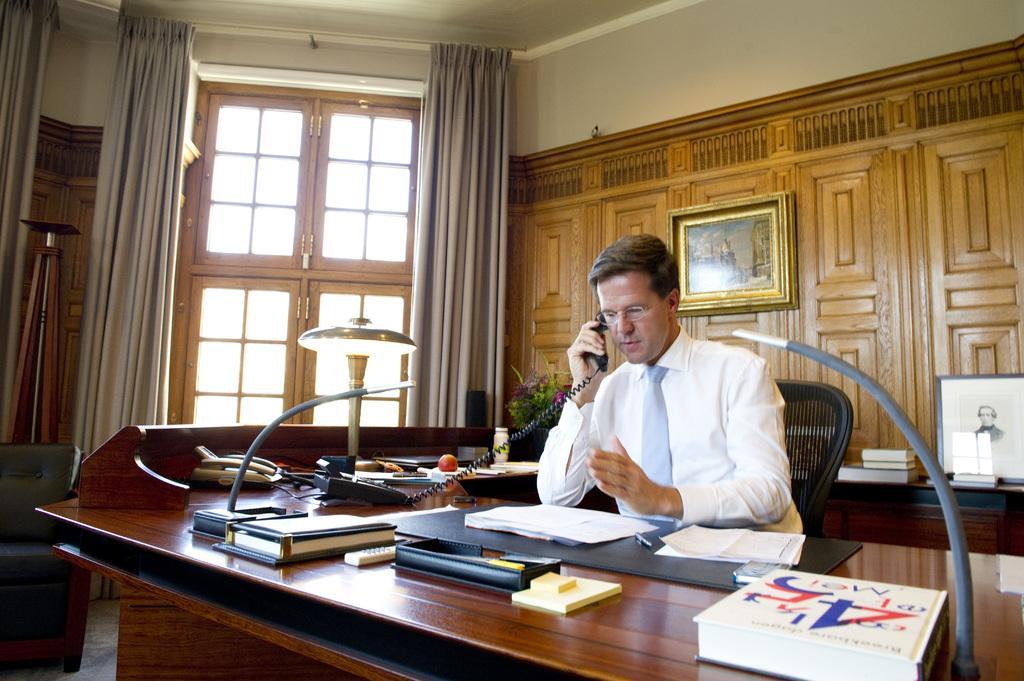Please provide a concise description of this image. This is an inside view of a room. Here I can see a man wearing white color shirt, sitting on the chair and speaking on the telephone which is placed on the table. On this table I can see few books, papers, remote, apple, telephone and some other objects. At the back of this man there is another table on which I can see few books and also there is a wall to which two frames are attached. In the background there is a window. On the both sides of this window I can see the curtains. 